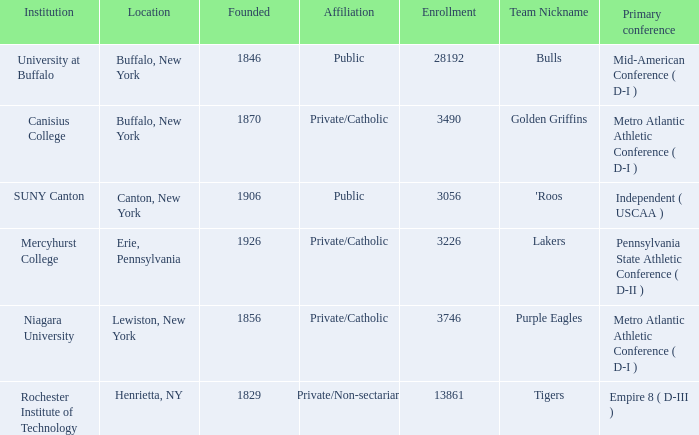What affiliation is Erie, Pennsylvania? Private/Catholic. 